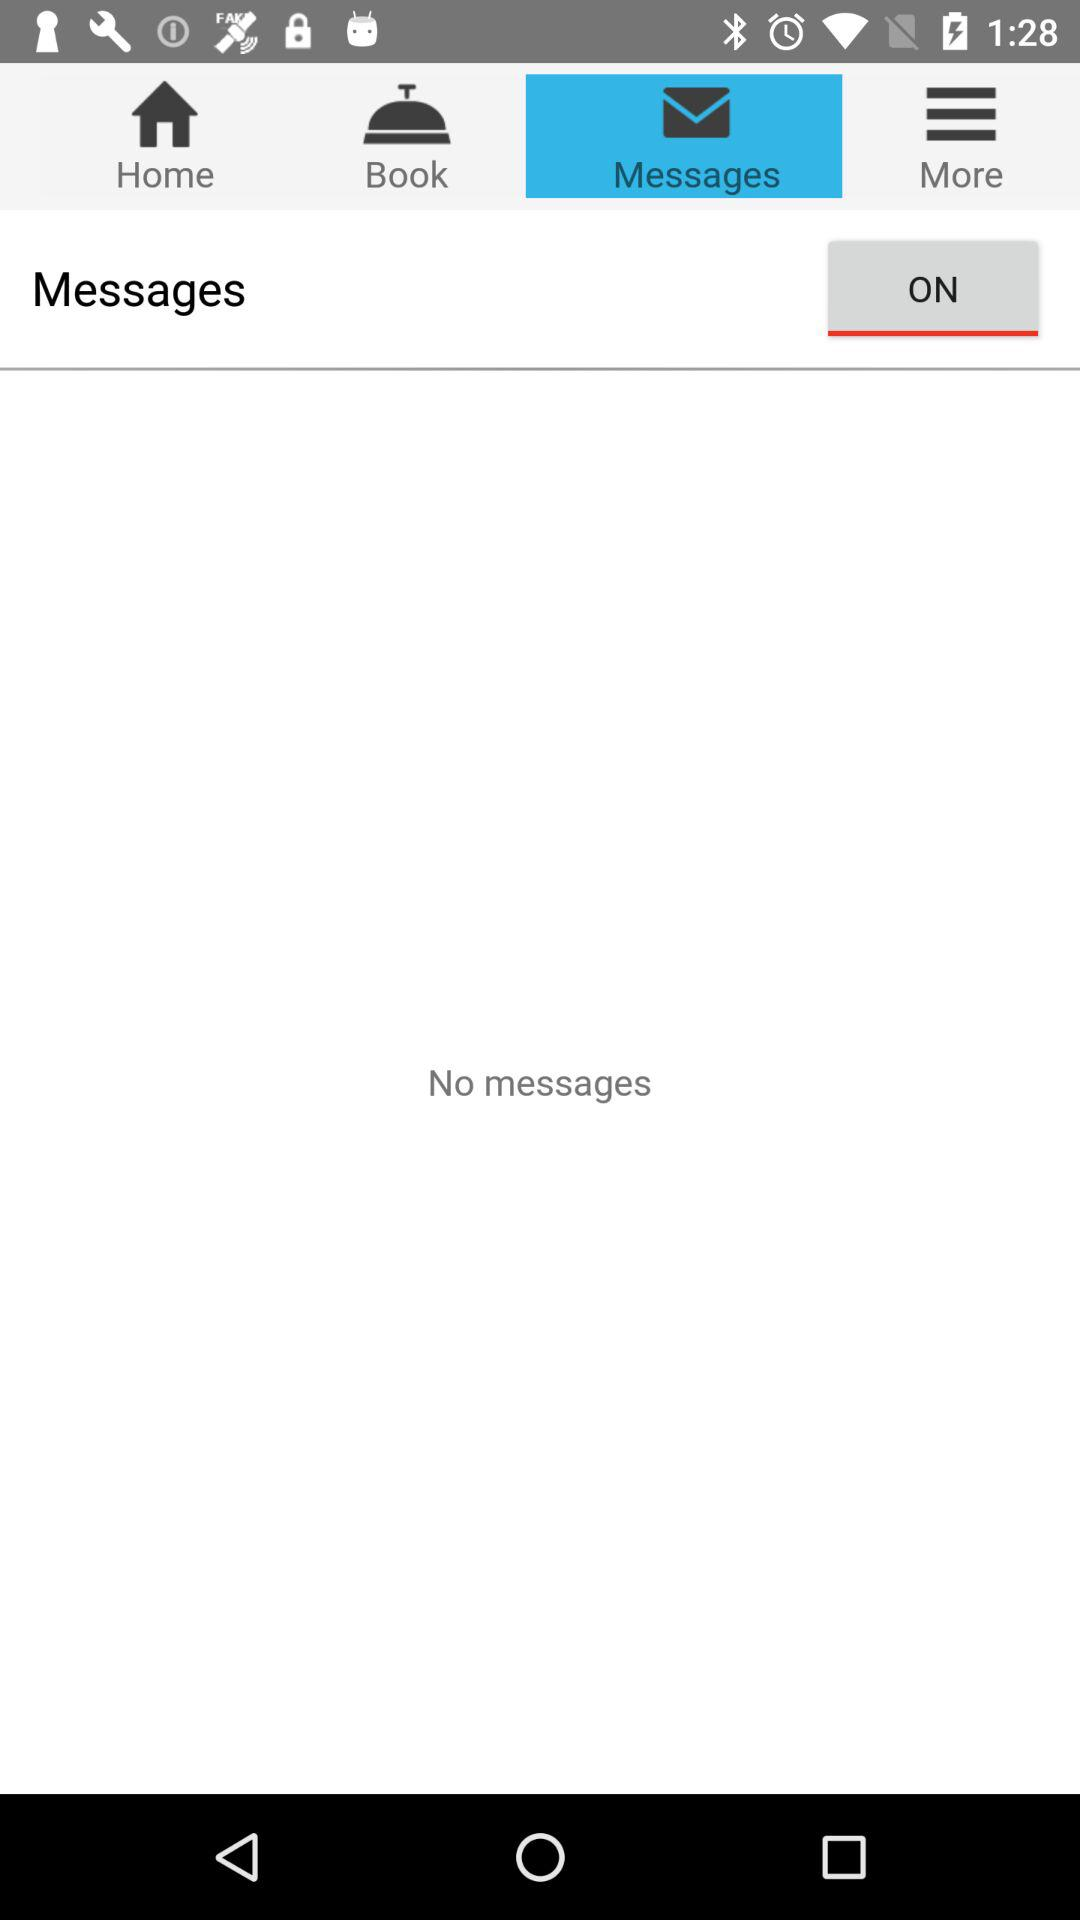What is the status of "Messages"? The status is "on". 